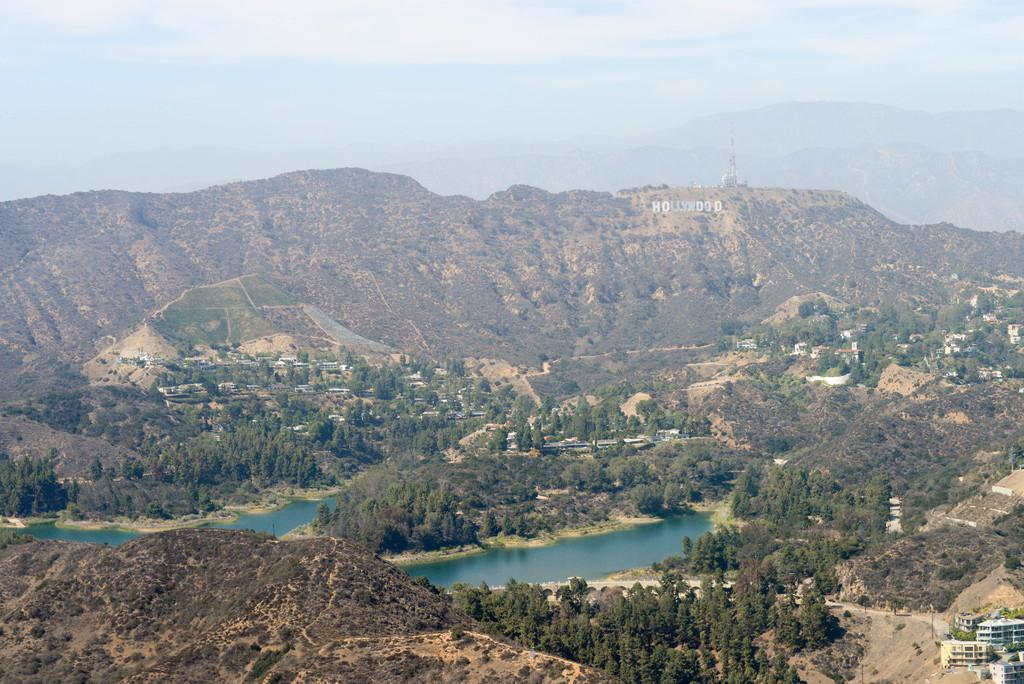What type of natural formation is visible in the image? There are mountains in the image. What covers the mountains in the image? The mountains are covered with trees. What type of structures can be seen in the image? There are buildings in the image. What is the condition of the sky in the image? The sky is clear in the image. What reward does the dad receive for climbing the mountain in the image? There is no dad or reward present in the image; it only features mountains, trees, buildings, and a clear sky. 